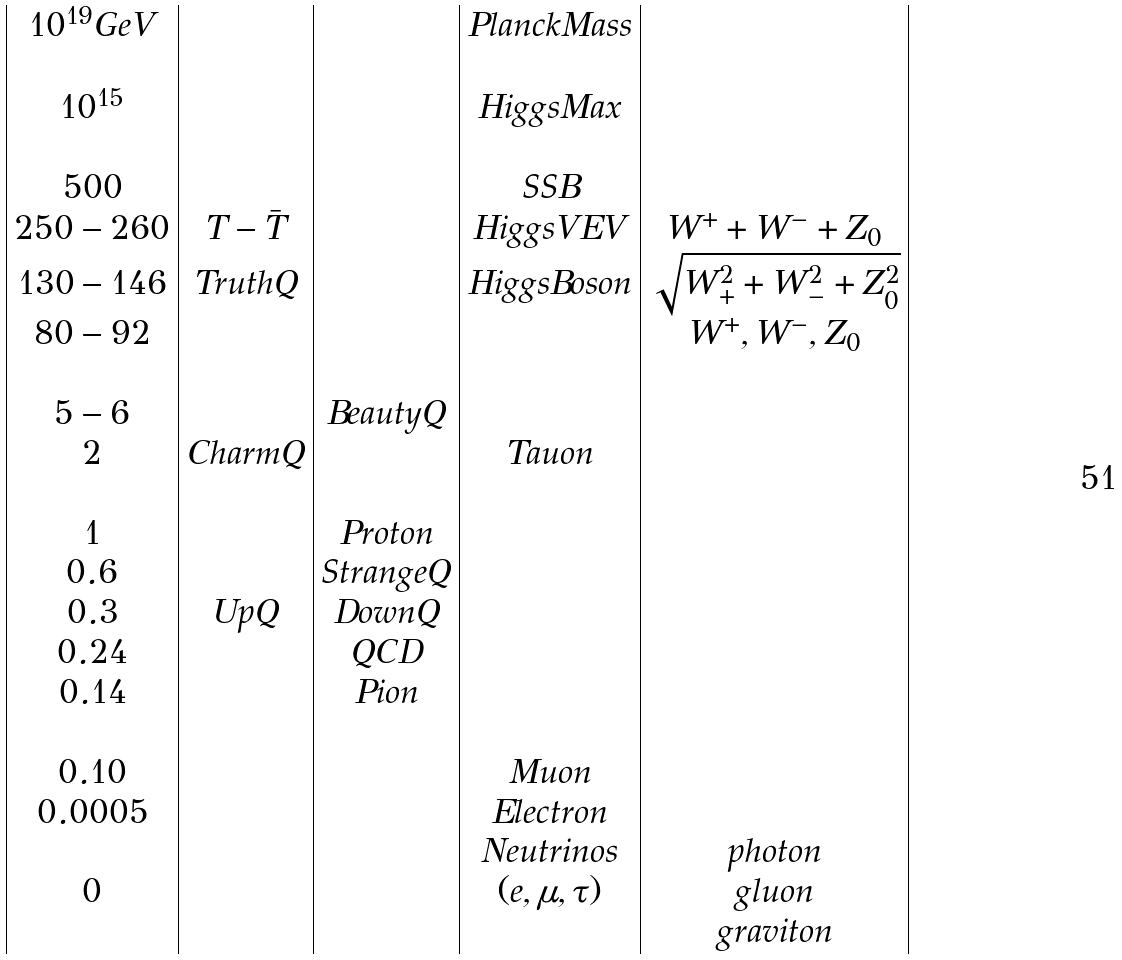<formula> <loc_0><loc_0><loc_500><loc_500>\begin{array} { | c | c | c | c | c | } 1 0 ^ { 1 9 } G e V & & & P l a n c k M a s s & \\ & & & & \\ 1 0 ^ { 1 5 } & & & H i g g s M a x & \\ & & & & \\ 5 0 0 & & & S S B & \\ 2 5 0 - 2 6 0 & T - \bar { T } & & H i g g s V E V & W ^ { + } + W ^ { - } + Z _ { 0 } \\ 1 3 0 - 1 4 6 & T r u t h Q & & H i g g s B o s o n & \sqrt { W _ { + } ^ { 2 } + W _ { - } ^ { 2 } + Z _ { 0 } ^ { 2 } } \\ 8 0 - 9 2 & & & & W ^ { + } , W ^ { - } , Z _ { 0 } \\ & & & & \\ 5 - 6 & & B e a u t y Q & & \\ 2 & C h a r m Q & & T a u o n & \\ & & & & \\ 1 & & P r o t o n & & \\ 0 . 6 & & S t r a n g e Q & & \\ 0 . 3 & U p Q & D o w n Q & & \\ 0 . 2 4 & & Q C D & & \\ 0 . 1 4 & & P i o n & & \\ & & & & \\ 0 . 1 0 & & & M u o n & \\ 0 . 0 0 0 5 & & & E l e c t r o n & \\ & & & N e u t r i n o s & p h o t o n \\ 0 & & & ( e , \mu , \tau ) & g l u o n \\ & & & & g r a v i t o n \\ \end{array}</formula> 